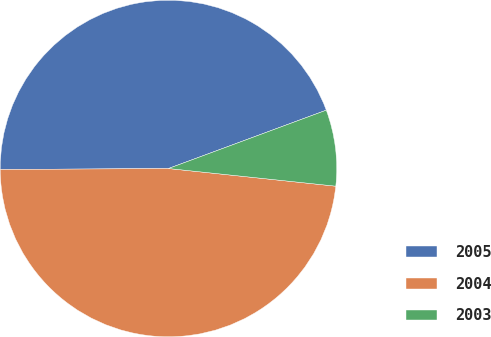<chart> <loc_0><loc_0><loc_500><loc_500><pie_chart><fcel>2005<fcel>2004<fcel>2003<nl><fcel>44.46%<fcel>48.23%<fcel>7.31%<nl></chart> 